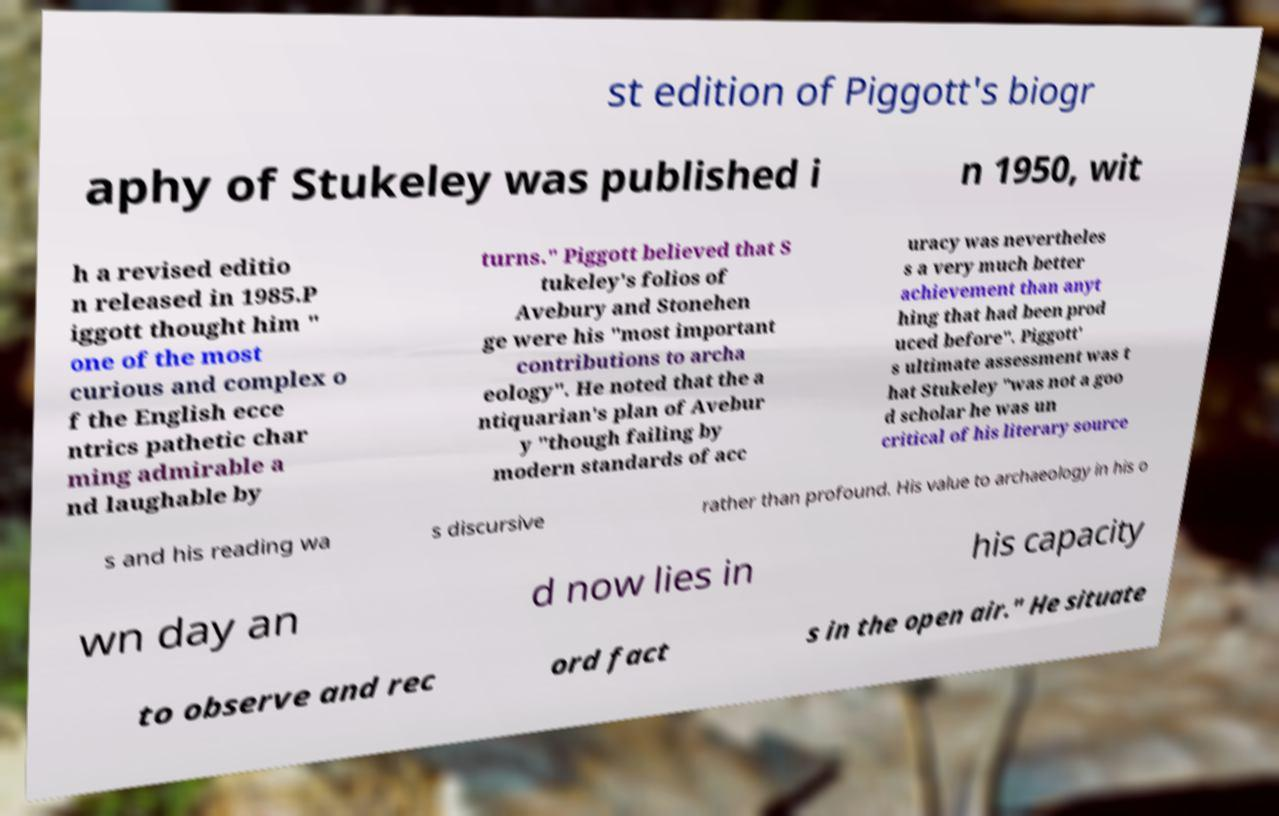Please read and relay the text visible in this image. What does it say? st edition of Piggott's biogr aphy of Stukeley was published i n 1950, wit h a revised editio n released in 1985.P iggott thought him " one of the most curious and complex o f the English ecce ntrics pathetic char ming admirable a nd laughable by turns." Piggott believed that S tukeley's folios of Avebury and Stonehen ge were his "most important contributions to archa eology". He noted that the a ntiquarian's plan of Avebur y "though failing by modern standards of acc uracy was nevertheles s a very much better achievement than anyt hing that had been prod uced before". Piggott' s ultimate assessment was t hat Stukeley "was not a goo d scholar he was un critical of his literary source s and his reading wa s discursive rather than profound. His value to archaeology in his o wn day an d now lies in his capacity to observe and rec ord fact s in the open air." He situate 